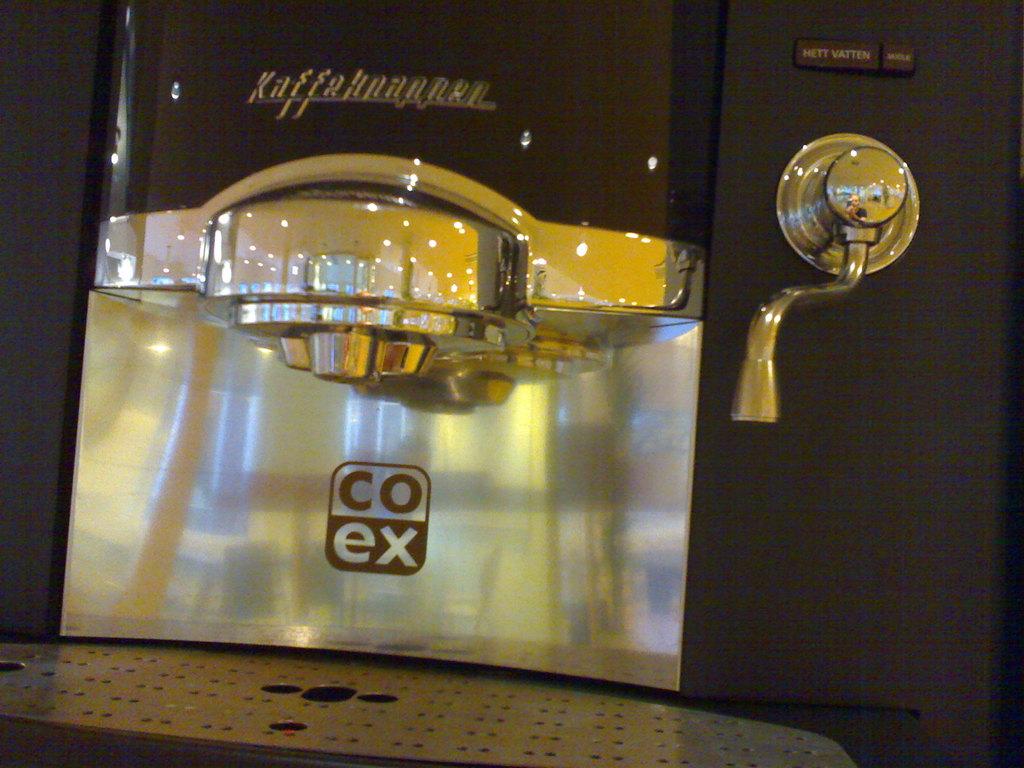What brand is this?
Provide a succinct answer. Coex. What are the four letters shown on this coffee brewer?
Offer a terse response. Coex. 